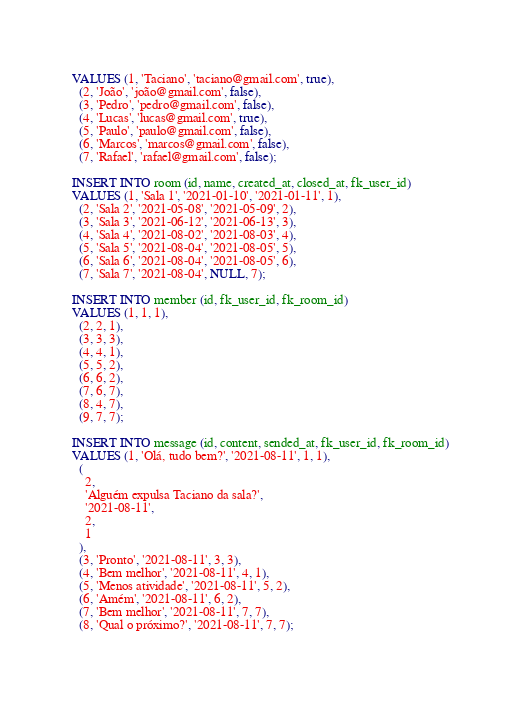<code> <loc_0><loc_0><loc_500><loc_500><_SQL_>VALUES (1, 'Taciano', 'taciano@gmail.com', true),
  (2, 'João', 'joão@gmail.com', false),
  (3, 'Pedro', 'pedro@gmail.com', false),
  (4, 'Lucas', 'lucas@gmail.com', true),
  (5, 'Paulo', 'paulo@gmail.com', false),
  (6, 'Marcos', 'marcos@gmail.com', false),
  (7, 'Rafael', 'rafael@gmail.com', false);

INSERT INTO room (id, name, created_at, closed_at, fk_user_id)
VALUES (1, 'Sala 1', '2021-01-10', '2021-01-11', 1),
  (2, 'Sala 2', '2021-05-08', '2021-05-09', 2),
  (3, 'Sala 3', '2021-06-12', '2021-06-13', 3),
  (4, 'Sala 4', '2021-08-02', '2021-08-03', 4),
  (5, 'Sala 5', '2021-08-04', '2021-08-05', 5),
  (6, 'Sala 6', '2021-08-04', '2021-08-05', 6),
  (7, 'Sala 7', '2021-08-04', NULL, 7);

INSERT INTO member (id, fk_user_id, fk_room_id)
VALUES (1, 1, 1),
  (2, 2, 1),
  (3, 3, 3),
  (4, 4, 1),
  (5, 5, 2),
  (6, 6, 2),
  (7, 6, 7),
  (8, 4, 7),
  (9, 7, 7);

INSERT INTO message (id, content, sended_at, fk_user_id, fk_room_id)
VALUES (1, 'Olá, tudo bem?', '2021-08-11', 1, 1),
  (
    2,
    'Alguém expulsa Taciano da sala?',
    '2021-08-11',
    2,
    1
  ),
  (3, 'Pronto', '2021-08-11', 3, 3),
  (4, 'Bem melhor', '2021-08-11', 4, 1),
  (5, 'Menos atividade', '2021-08-11', 5, 2),
  (6, 'Amém', '2021-08-11', 6, 2),
  (7, 'Bem melhor', '2021-08-11', 7, 7),
  (8, 'Qual o próximo?', '2021-08-11', 7, 7);

</code> 